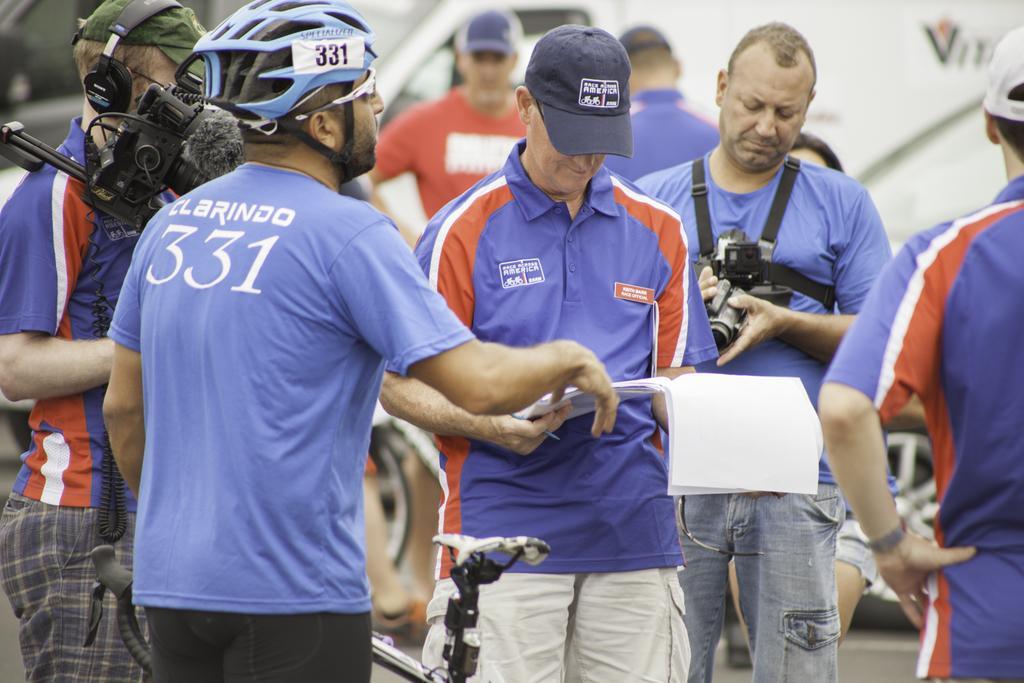Please provide a concise description of this image. In this image, we can see some persons standing and wearing clothes. There is a person in the middle of the image holding some papers. There is an another person on the right side of the image holding a camera. In the background, image is blurred. 